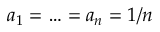<formula> <loc_0><loc_0><loc_500><loc_500>a _ { 1 } = \dots = a _ { n } = 1 / n</formula> 